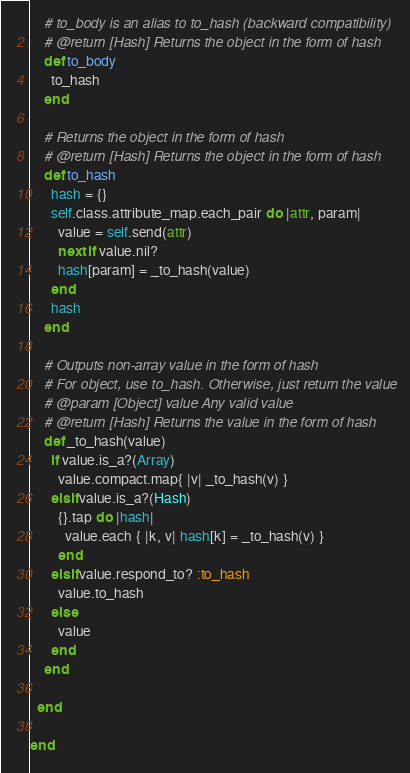<code> <loc_0><loc_0><loc_500><loc_500><_Ruby_>
    # to_body is an alias to to_hash (backward compatibility)
    # @return [Hash] Returns the object in the form of hash
    def to_body
      to_hash
    end

    # Returns the object in the form of hash
    # @return [Hash] Returns the object in the form of hash
    def to_hash
      hash = {}
      self.class.attribute_map.each_pair do |attr, param|
        value = self.send(attr)
        next if value.nil?
        hash[param] = _to_hash(value)
      end
      hash
    end

    # Outputs non-array value in the form of hash
    # For object, use to_hash. Otherwise, just return the value
    # @param [Object] value Any valid value
    # @return [Hash] Returns the value in the form of hash
    def _to_hash(value)
      if value.is_a?(Array)
        value.compact.map{ |v| _to_hash(v) }
      elsif value.is_a?(Hash)
        {}.tap do |hash|
          value.each { |k, v| hash[k] = _to_hash(v) }
        end
      elsif value.respond_to? :to_hash
        value.to_hash
      else
        value
      end
    end

  end

end
</code> 